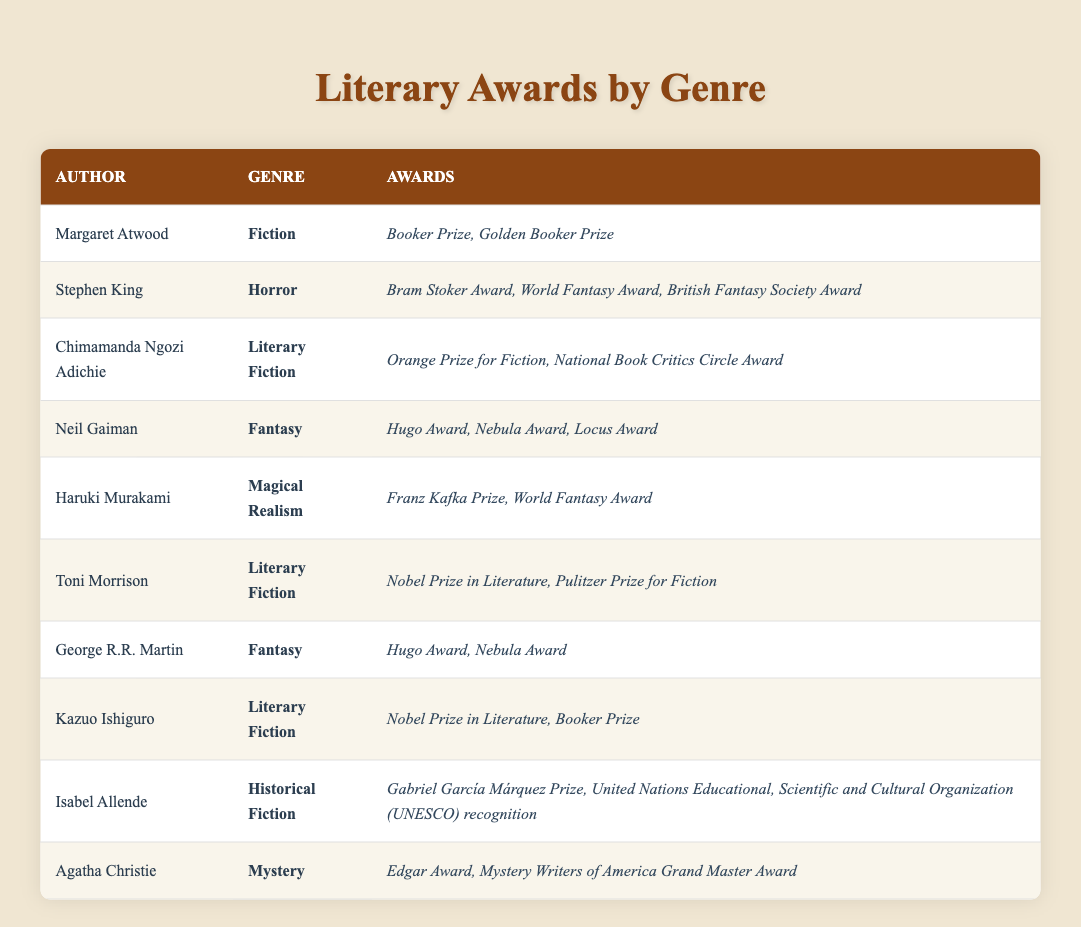What is the genre of Margaret Atwood's works? The table shows that Margaret Atwood is listed under the genre "Fiction".
Answer: Fiction How many awards has Stephen King won? According to the table, Stephen King has won three awards: Bram Stoker Award, World Fantasy Award, and British Fantasy Society Award.
Answer: 3 Who has received the Nobel Prize in Literature among the authors listed? The table indicates that both Toni Morrison and Kazuo Ishiguro have been awarded the Nobel Prize in Literature.
Answer: Toni Morrison and Kazuo Ishiguro Which genres have authors that received the Hugo Award? The table shows that both Neil Gaiman and George R.R. Martin, who write in the Fantasy genre, have received the Hugo Award. Hence, the genre is "Fantasy".
Answer: Fantasy Is Agatha Christie the only author listed who writes in the Mystery genre? The table indicates that Agatha Christie is the sole author linked to the Mystery genre, confirming that she is indeed the only one.
Answer: Yes What is the total number of awards won by Literary Fiction authors combined? The authors under Literary Fiction are Chimamanda Ngozi Adichie, Toni Morrison, and Kazuo Ishiguro. Adichie has 2 awards, Morrison has 2 awards, and Ishiguro has 2 awards. Summing these gives 2 + 2 + 2 = 6 awards.
Answer: 6 How many awards did authors in the Fantasy genre win in total? The table lists Neil Gaiman with 3 awards (Hugo, Nebula, Locus), and George R.R. Martin with 2 awards (Hugo, Nebula). Adding these awards gives 3 + 2 = 5 awards in total.
Answer: 5 Does any author under Historical Fiction category have more than two awards? The table shows that Isabel Allende has won 2 awards (Gabriel García Márquez Prize, UNESCO recognition), which does not exceed two. Therefore, the answer is no.
Answer: No What is the difference in the number of awards between the authors of Literary Fiction and Fiction genres? Literary Fiction includes 3 authors with a total of 6 awards (Adichie: 2, Morrison: 2, Ishiguro: 2), while the Fiction genre (Atwood) has 2 awards. The difference is 6 - 2 = 4.
Answer: 4 